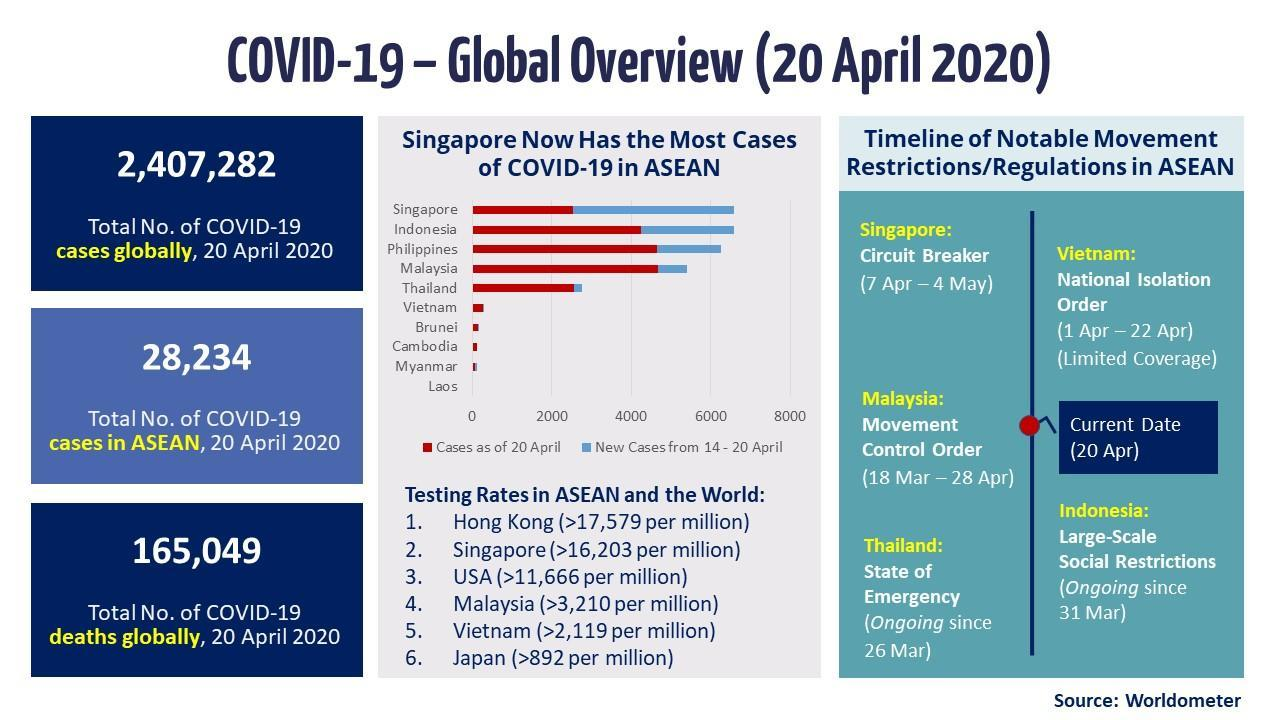When was the 2020 singapore circuit breaker measures implemented as a preventive measure in response to COVID-19  pandemic?
Answer the question with a short phrase. 7 Apr - 4 May What is the total no of COVID-19 cases in ASEAN as of 20 April 2020? 28,234 What is the total no of COVID-19 deaths globally as of 20 April 2020? 165,049 What is the total no of COVID-19 cases globally as of 20 April 2020? 2,407,282 When was the movement control order implemented in Malaysia as a preventive measure in response to COVID-19  pandemic in 2020? 18 Mar - 28 Apr 